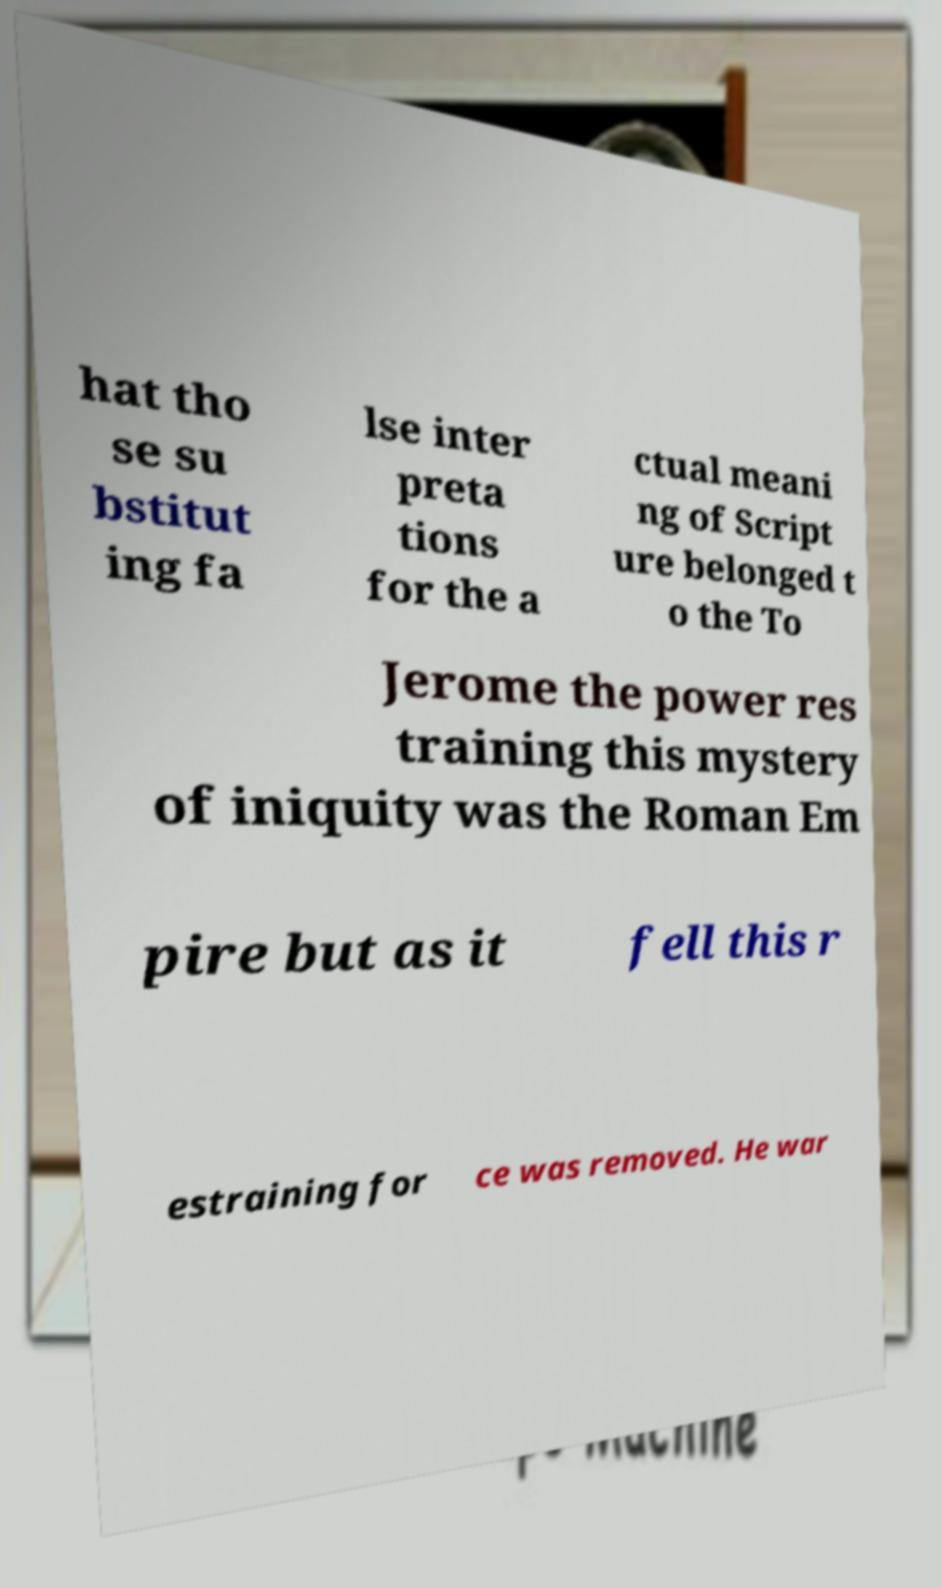Please identify and transcribe the text found in this image. hat tho se su bstitut ing fa lse inter preta tions for the a ctual meani ng of Script ure belonged t o the To Jerome the power res training this mystery of iniquity was the Roman Em pire but as it fell this r estraining for ce was removed. He war 